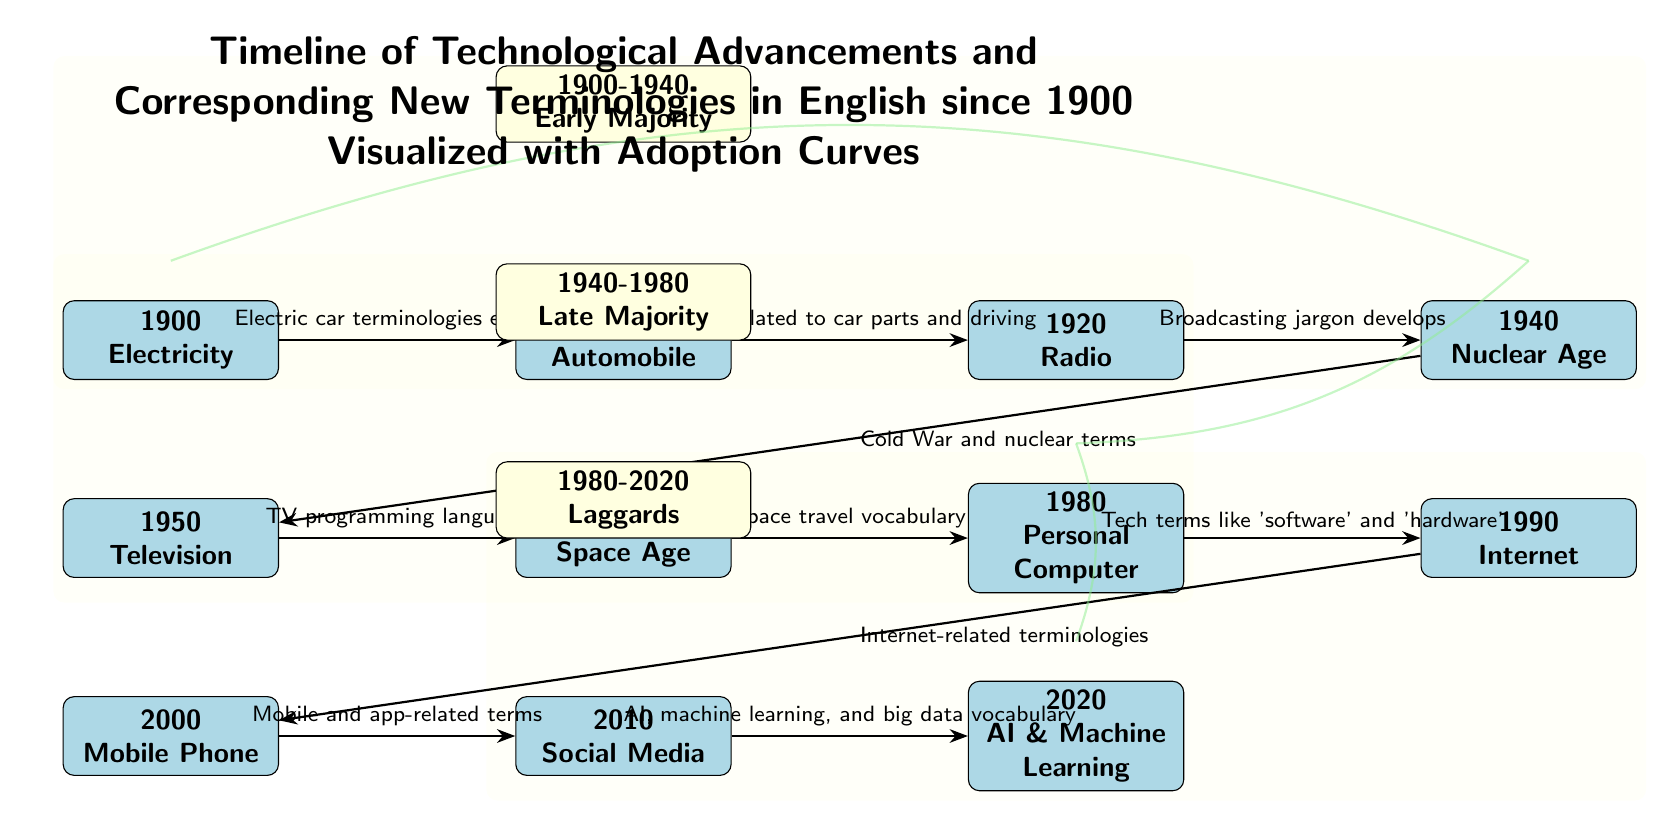What technological advancement corresponds to the year 2000? Looking at the node labeled "2000," it clearly indicates "Mobile Phone" as the technological advancement associated with that year.
Answer: Mobile Phone How many technological advancements are depicted in the diagram? By counting the nodes in the diagram, there are 11 advancements shown, ranging from 1900 to 2020.
Answer: 11 What terminology emerges between 1940 and 1950? The edge connecting the nodes "1940" and "1950" states "TV programming language," indicating that terminology related to television emerged during this period.
Answer: TV programming language What is the period labeled above the 2010 node? According to the diagram, above the 2010 node, the period is labeled "1980-2020" corresponding to the "Laggards" category.
Answer: 1980-2020 Laggards Which technological advancement is connected to the "Cold War and nuclear terms"? The arrow leading to the node labeled "1950" points from "1940" and is marked with "Cold War and nuclear terms," indicating this connection.
Answer: Television What type of vocabulary developed with the emergence of the Internet in 1990? The edge leading from "1990" to "2000" reads "Internet-related terminologies," detailing the type of vocabulary that emerged with the Internet's introduction.
Answer: Internet-related terminologies What describes the transition of vocabulary from 1980 to 1990? The transition from "1980" to "1990" includes terms like 'software' and 'hardware,' indicating the technological shift that occurred at this time.
Answer: Tech terms like 'software' and 'hardware' How many distinct periods are identified in the diagram? There are three distinct periods indicated in the diagram, each with its specific labels for different technological phases.
Answer: 3 Which edge describes the relationship between the Automobiles and Radio terminologies? The edge from "1910" to "1920" specifies that terms related to car parts and driving emerged as a connection to "Radio."
Answer: Terms related to car parts and driving 